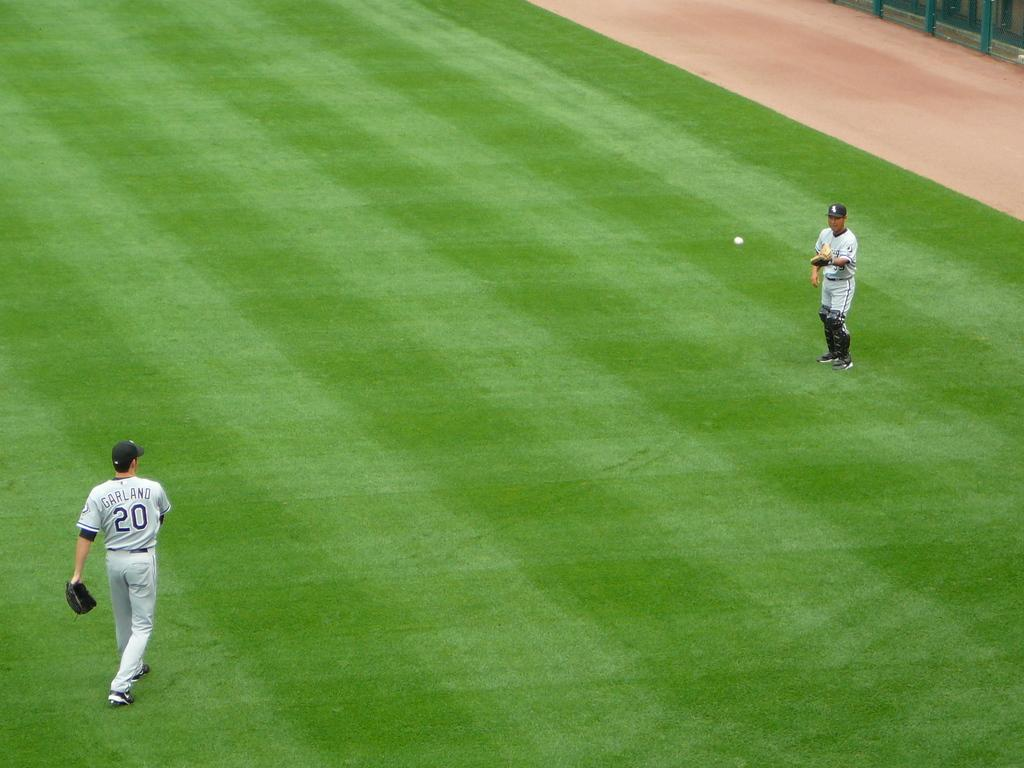<image>
Provide a brief description of the given image. A baseball player with number 20 throws the ball to another player. 